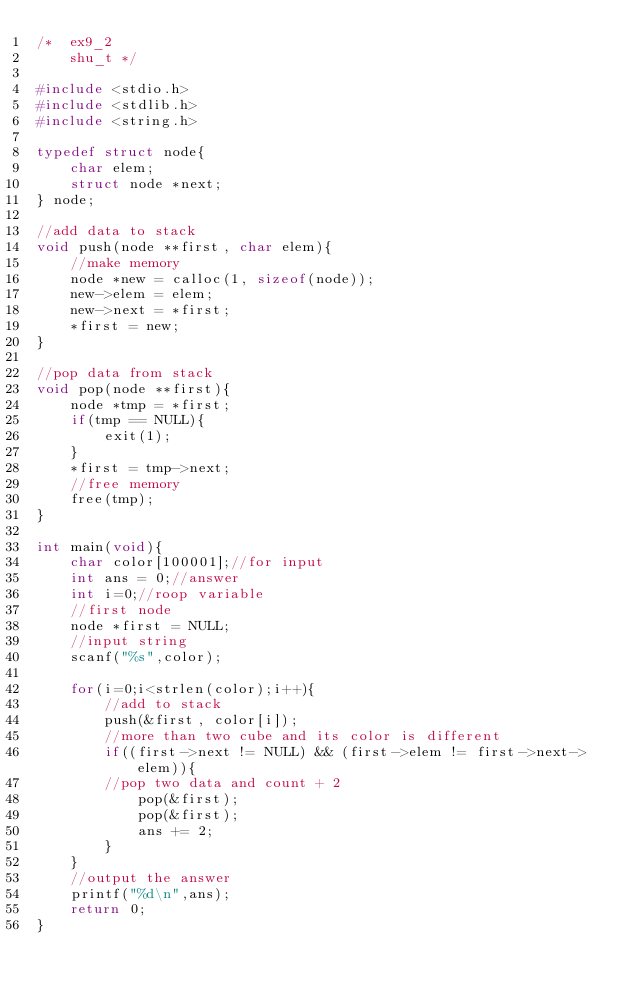<code> <loc_0><loc_0><loc_500><loc_500><_C_>/*  ex9_2
    shu_t */

#include <stdio.h>
#include <stdlib.h>
#include <string.h>

typedef struct node{
    char elem;
    struct node *next;
} node;

//add data to stack
void push(node **first, char elem){
    //make memory
    node *new = calloc(1, sizeof(node));
    new->elem = elem;
    new->next = *first;
    *first = new;
}

//pop data from stack
void pop(node **first){
    node *tmp = *first;
    if(tmp == NULL){
        exit(1);
    }
    *first = tmp->next;
    //free memory
    free(tmp);
}

int main(void){
    char color[100001];//for input
    int ans = 0;//answer
    int i=0;//roop variable
    //first node
    node *first = NULL;
    //input string
    scanf("%s",color);
    
    for(i=0;i<strlen(color);i++){
        //add to stack
        push(&first, color[i]);
        //more than two cube and its color is different
        if((first->next != NULL) && (first->elem != first->next->elem)){
        //pop two data and count + 2
            pop(&first);
            pop(&first);
            ans += 2;
        }
    }
    //output the answer
    printf("%d\n",ans);
    return 0;
}</code> 